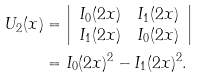Convert formula to latex. <formula><loc_0><loc_0><loc_500><loc_500>U _ { 2 } ( x ) & = \left | \begin{array} { c c } I _ { 0 } ( 2 x ) & I _ { 1 } ( 2 x ) \\ I _ { 1 } ( 2 x ) & I _ { 0 } ( 2 x ) \end{array} \right | \\ & = I _ { 0 } ( 2 x ) ^ { 2 } - I _ { 1 } ( 2 x ) ^ { 2 } .</formula> 